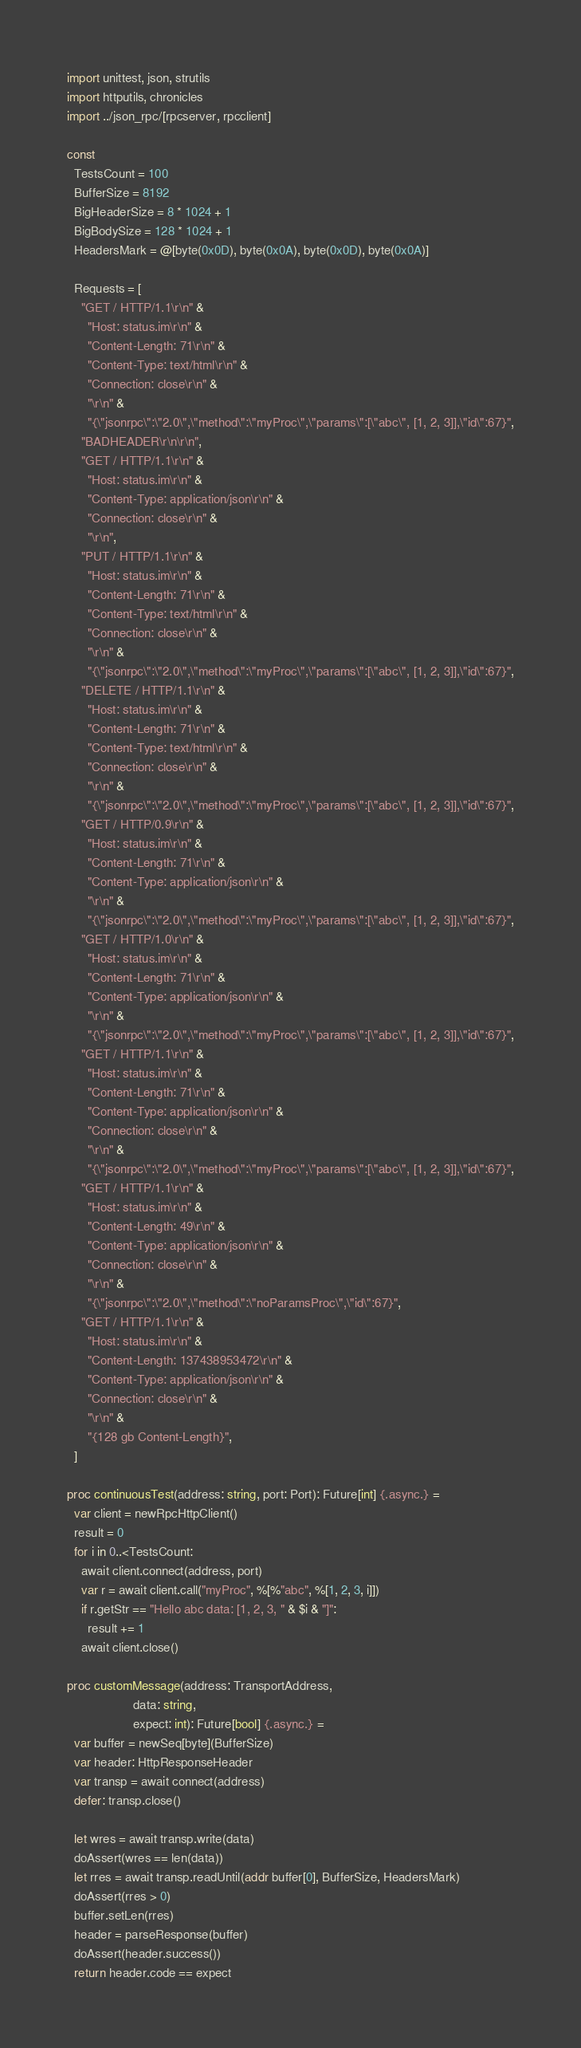Convert code to text. <code><loc_0><loc_0><loc_500><loc_500><_Nim_>import unittest, json, strutils
import httputils, chronicles
import ../json_rpc/[rpcserver, rpcclient]

const
  TestsCount = 100
  BufferSize = 8192
  BigHeaderSize = 8 * 1024 + 1
  BigBodySize = 128 * 1024 + 1
  HeadersMark = @[byte(0x0D), byte(0x0A), byte(0x0D), byte(0x0A)]

  Requests = [
    "GET / HTTP/1.1\r\n" &
      "Host: status.im\r\n" &
      "Content-Length: 71\r\n" &
      "Content-Type: text/html\r\n" &
      "Connection: close\r\n" &
      "\r\n" &
      "{\"jsonrpc\":\"2.0\",\"method\":\"myProc\",\"params\":[\"abc\", [1, 2, 3]],\"id\":67}",
    "BADHEADER\r\n\r\n",
    "GET / HTTP/1.1\r\n" &
      "Host: status.im\r\n" &
      "Content-Type: application/json\r\n" &
      "Connection: close\r\n" &
      "\r\n",
    "PUT / HTTP/1.1\r\n" &
      "Host: status.im\r\n" &
      "Content-Length: 71\r\n" &
      "Content-Type: text/html\r\n" &
      "Connection: close\r\n" &
      "\r\n" &
      "{\"jsonrpc\":\"2.0\",\"method\":\"myProc\",\"params\":[\"abc\", [1, 2, 3]],\"id\":67}",
    "DELETE / HTTP/1.1\r\n" &
      "Host: status.im\r\n" &
      "Content-Length: 71\r\n" &
      "Content-Type: text/html\r\n" &
      "Connection: close\r\n" &
      "\r\n" &
      "{\"jsonrpc\":\"2.0\",\"method\":\"myProc\",\"params\":[\"abc\", [1, 2, 3]],\"id\":67}",
    "GET / HTTP/0.9\r\n" &
      "Host: status.im\r\n" &
      "Content-Length: 71\r\n" &
      "Content-Type: application/json\r\n" &
      "\r\n" &
      "{\"jsonrpc\":\"2.0\",\"method\":\"myProc\",\"params\":[\"abc\", [1, 2, 3]],\"id\":67}",
    "GET / HTTP/1.0\r\n" &
      "Host: status.im\r\n" &
      "Content-Length: 71\r\n" &
      "Content-Type: application/json\r\n" &
      "\r\n" &
      "{\"jsonrpc\":\"2.0\",\"method\":\"myProc\",\"params\":[\"abc\", [1, 2, 3]],\"id\":67}",
    "GET / HTTP/1.1\r\n" &
      "Host: status.im\r\n" &
      "Content-Length: 71\r\n" &
      "Content-Type: application/json\r\n" &
      "Connection: close\r\n" &
      "\r\n" &
      "{\"jsonrpc\":\"2.0\",\"method\":\"myProc\",\"params\":[\"abc\", [1, 2, 3]],\"id\":67}",
    "GET / HTTP/1.1\r\n" &
      "Host: status.im\r\n" &
      "Content-Length: 49\r\n" &
      "Content-Type: application/json\r\n" &
      "Connection: close\r\n" &
      "\r\n" &
      "{\"jsonrpc\":\"2.0\",\"method\":\"noParamsProc\",\"id\":67}",
    "GET / HTTP/1.1\r\n" &
      "Host: status.im\r\n" &
      "Content-Length: 137438953472\r\n" &
      "Content-Type: application/json\r\n" &
      "Connection: close\r\n" &
      "\r\n" &
      "{128 gb Content-Length}",
  ]

proc continuousTest(address: string, port: Port): Future[int] {.async.} =
  var client = newRpcHttpClient()
  result = 0
  for i in 0..<TestsCount:
    await client.connect(address, port)
    var r = await client.call("myProc", %[%"abc", %[1, 2, 3, i]])
    if r.getStr == "Hello abc data: [1, 2, 3, " & $i & "]":
      result += 1
    await client.close()

proc customMessage(address: TransportAddress,
                   data: string,
                   expect: int): Future[bool] {.async.} =
  var buffer = newSeq[byte](BufferSize)
  var header: HttpResponseHeader
  var transp = await connect(address)
  defer: transp.close()

  let wres = await transp.write(data)
  doAssert(wres == len(data))
  let rres = await transp.readUntil(addr buffer[0], BufferSize, HeadersMark)
  doAssert(rres > 0)
  buffer.setLen(rres)
  header = parseResponse(buffer)
  doAssert(header.success())
  return header.code == expect
</code> 